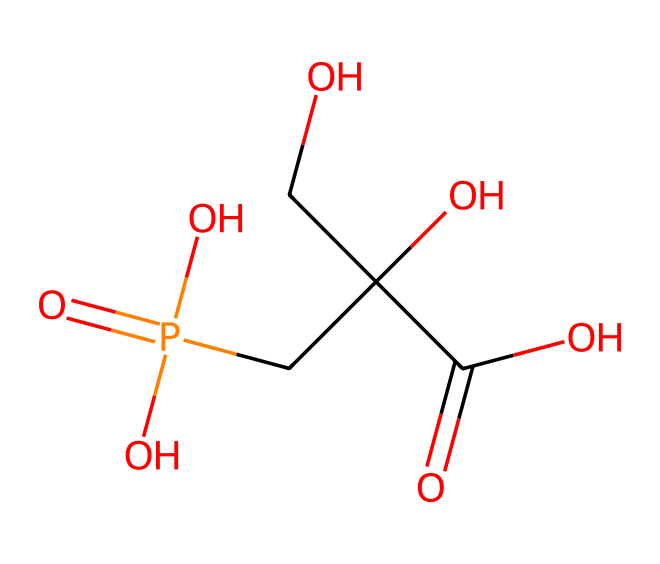What is the primary functional group in glyphosate? The chemical structure has a carboxylic acid group (-COOH), which is indicated by the C(=O)O part of the SMILES.
Answer: carboxylic acid How many carbon atoms are present in glyphosate? In the SMILES representation, counting the 'C' characters reveals there are 3 carbon atoms connected through various bonds.
Answer: three What is the molecular formula for glyphosate? By analyzing the SMILES, we can derive the molecular formula by counting each type of atom: C, H, N, O, leading to C3H8N5O2P.
Answer: C3H8N5O2P Which element gives glyphosate its herbicidal activity? The phosphorus atom (P) is part of the structure, which is crucial for its function as a herbicide, influencing how it works in plants.
Answer: phosphorus Does glyphosate contain a nitrogen atom? The SMILES representation includes 'N', indicating the presence of one nitrogen atom, integral to the molecule's structure.
Answer: yes What type of herbicide is glyphosate categorized as? Glyphosate is a systemic herbicide, as it operates throughout the plant, targeting specific pathways; thus its structure supports this classification.
Answer: systemic herbicide How many hydroxyl (-OH) groups are present in glyphosate? Analyzing the SMILES structure, we can identify two -OH groups which are represented as -O and contribute to its properties.
Answer: two 